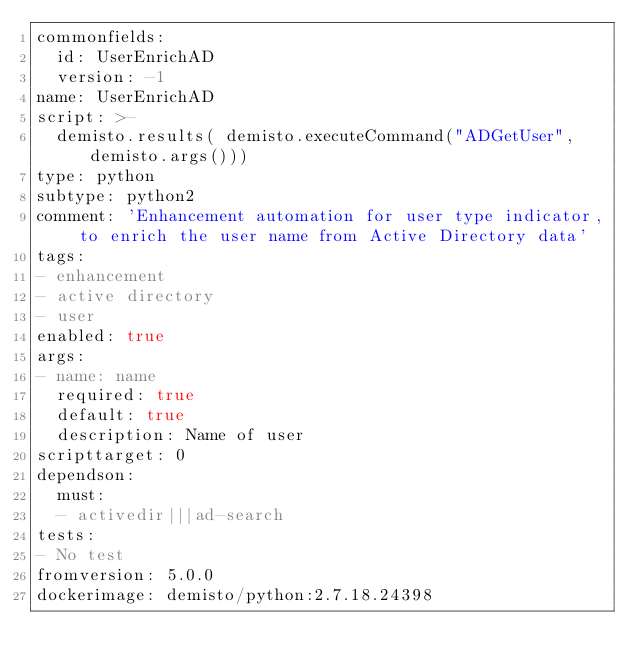<code> <loc_0><loc_0><loc_500><loc_500><_YAML_>commonfields:
  id: UserEnrichAD
  version: -1
name: UserEnrichAD
script: >-
  demisto.results( demisto.executeCommand("ADGetUser", demisto.args()))
type: python
subtype: python2
comment: 'Enhancement automation for user type indicator, to enrich the user name from Active Directory data'
tags:
- enhancement
- active directory
- user
enabled: true
args:
- name: name
  required: true
  default: true
  description: Name of user
scripttarget: 0
dependson:
  must:
  - activedir|||ad-search
tests:
- No test
fromversion: 5.0.0
dockerimage: demisto/python:2.7.18.24398
</code> 